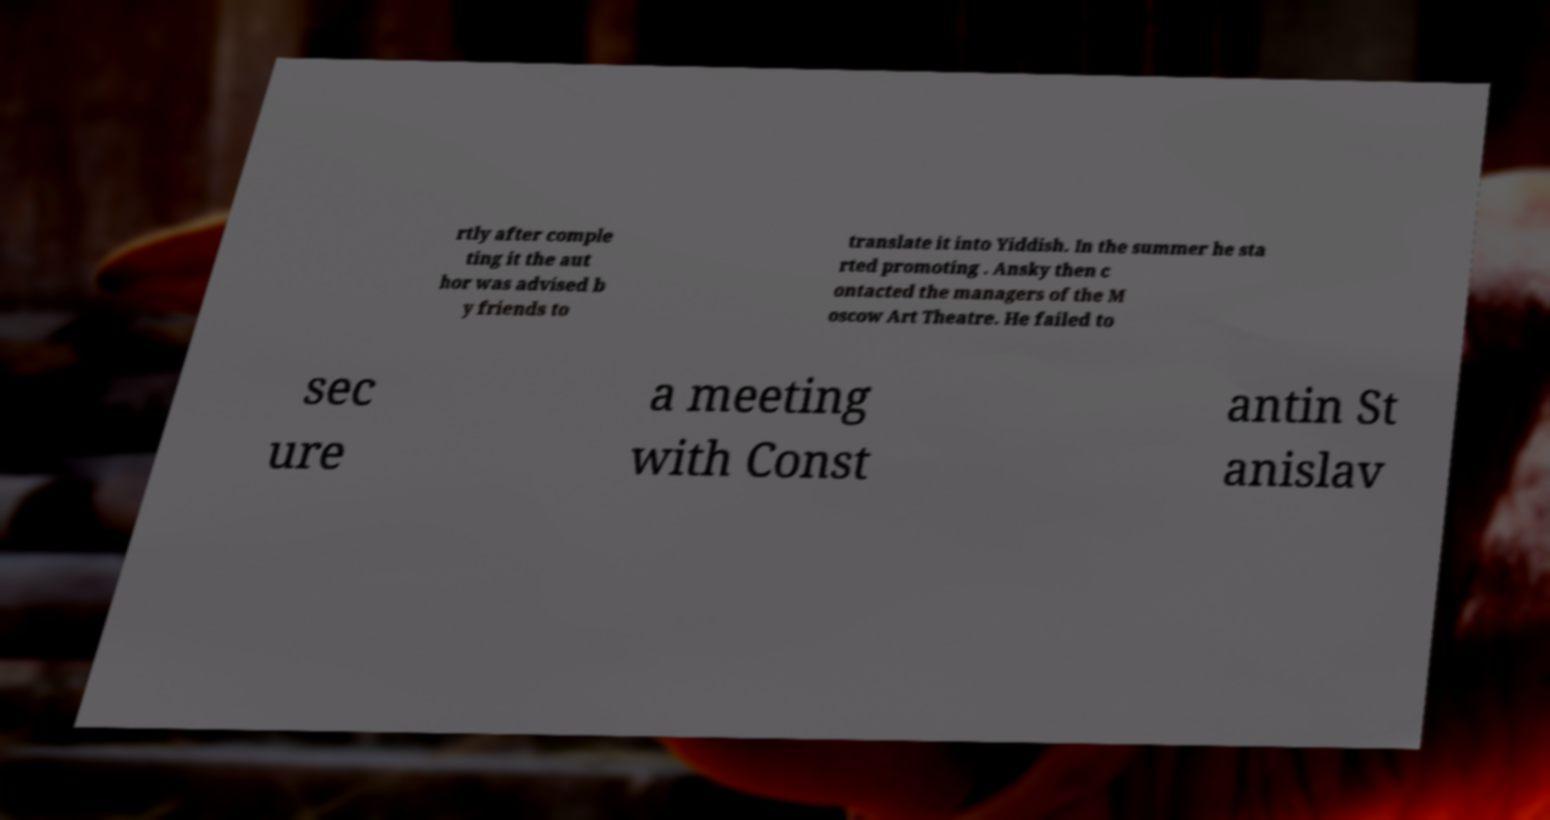Could you assist in decoding the text presented in this image and type it out clearly? rtly after comple ting it the aut hor was advised b y friends to translate it into Yiddish. In the summer he sta rted promoting . Ansky then c ontacted the managers of the M oscow Art Theatre. He failed to sec ure a meeting with Const antin St anislav 